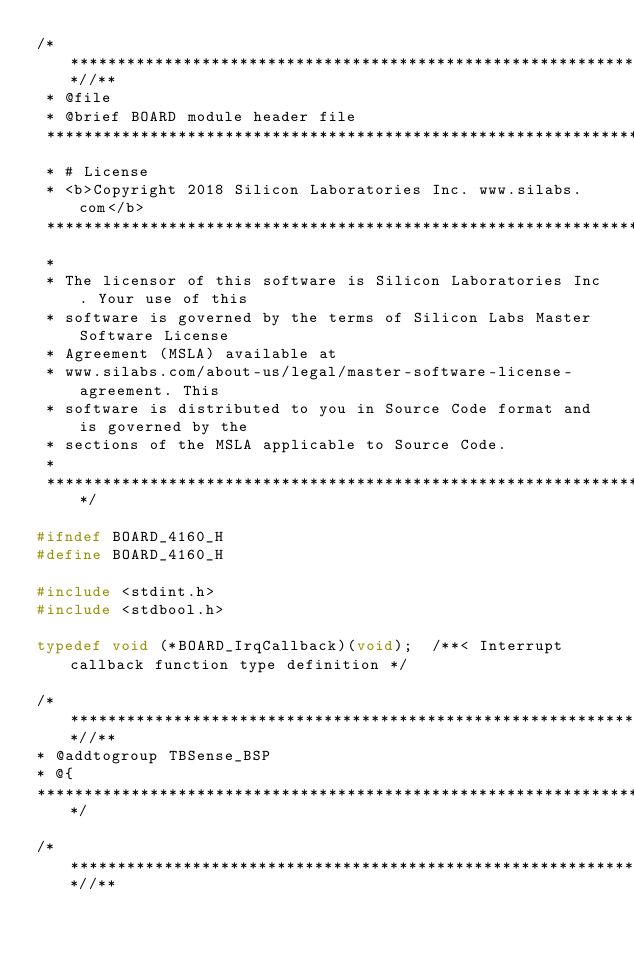<code> <loc_0><loc_0><loc_500><loc_500><_C_>/***************************************************************************//**
 * @file
 * @brief BOARD module header file
 *******************************************************************************
 * # License
 * <b>Copyright 2018 Silicon Laboratories Inc. www.silabs.com</b>
 *******************************************************************************
 *
 * The licensor of this software is Silicon Laboratories Inc. Your use of this
 * software is governed by the terms of Silicon Labs Master Software License
 * Agreement (MSLA) available at
 * www.silabs.com/about-us/legal/master-software-license-agreement. This
 * software is distributed to you in Source Code format and is governed by the
 * sections of the MSLA applicable to Source Code.
 *
 ******************************************************************************/

#ifndef BOARD_4160_H
#define BOARD_4160_H

#include <stdint.h>
#include <stdbool.h>

typedef void (*BOARD_IrqCallback)(void);  /**< Interrupt callback function type definition */

/**************************************************************************//**
* @addtogroup TBSense_BSP
* @{
******************************************************************************/

/***************************************************************************//**</code> 